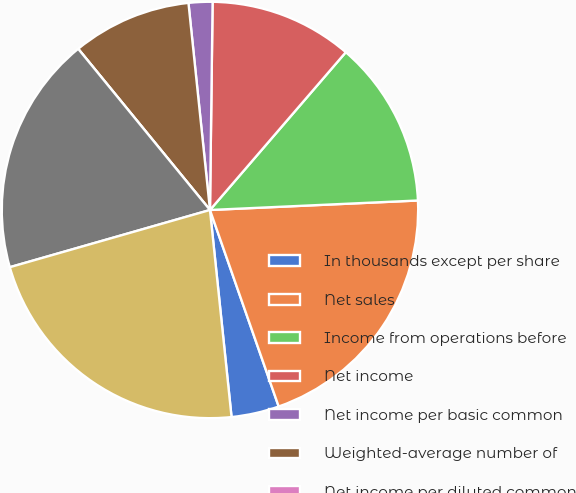<chart> <loc_0><loc_0><loc_500><loc_500><pie_chart><fcel>In thousands except per share<fcel>Net sales<fcel>Income from operations before<fcel>Net income<fcel>Net income per basic common<fcel>Weighted-average number of<fcel>Net income per diluted common<fcel>Cash cash equivalents and<fcel>Working capital including<nl><fcel>3.7%<fcel>20.37%<fcel>12.96%<fcel>11.11%<fcel>1.85%<fcel>9.26%<fcel>0.0%<fcel>18.52%<fcel>22.22%<nl></chart> 